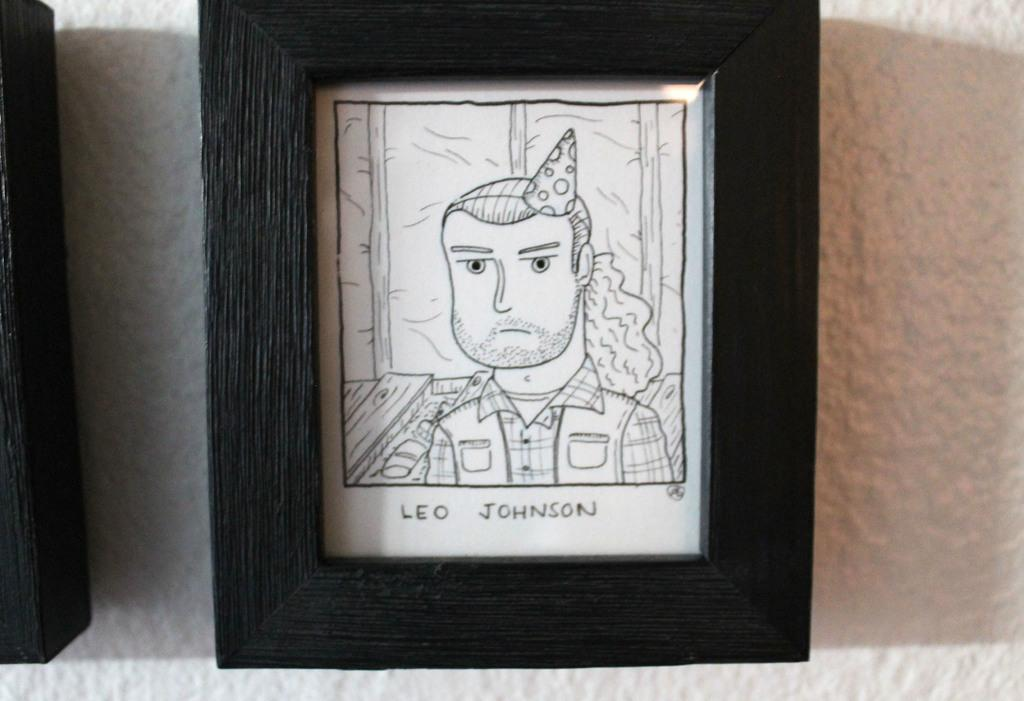<image>
Offer a succinct explanation of the picture presented. A drawing of a man in a party hat is labeled Leo Johnson. 